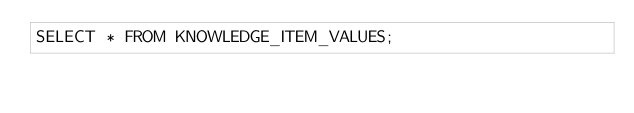Convert code to text. <code><loc_0><loc_0><loc_500><loc_500><_SQL_>SELECT * FROM KNOWLEDGE_ITEM_VALUES;
</code> 